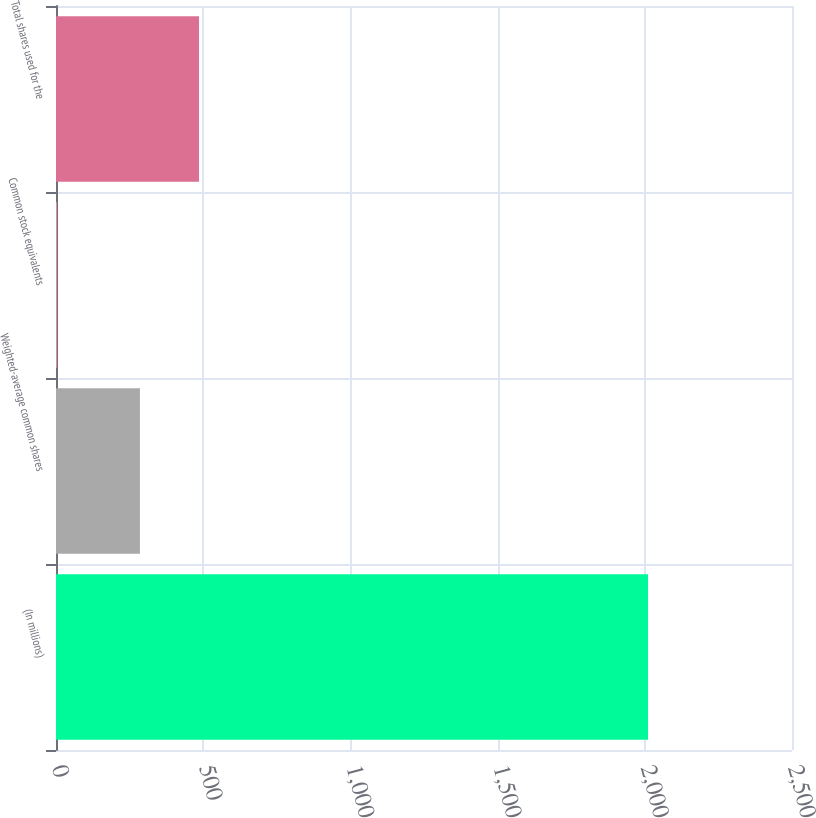Convert chart. <chart><loc_0><loc_0><loc_500><loc_500><bar_chart><fcel>(In millions)<fcel>Weighted-average common shares<fcel>Common stock equivalents<fcel>Total shares used for the<nl><fcel>2011<fcel>285.1<fcel>3.3<fcel>485.87<nl></chart> 